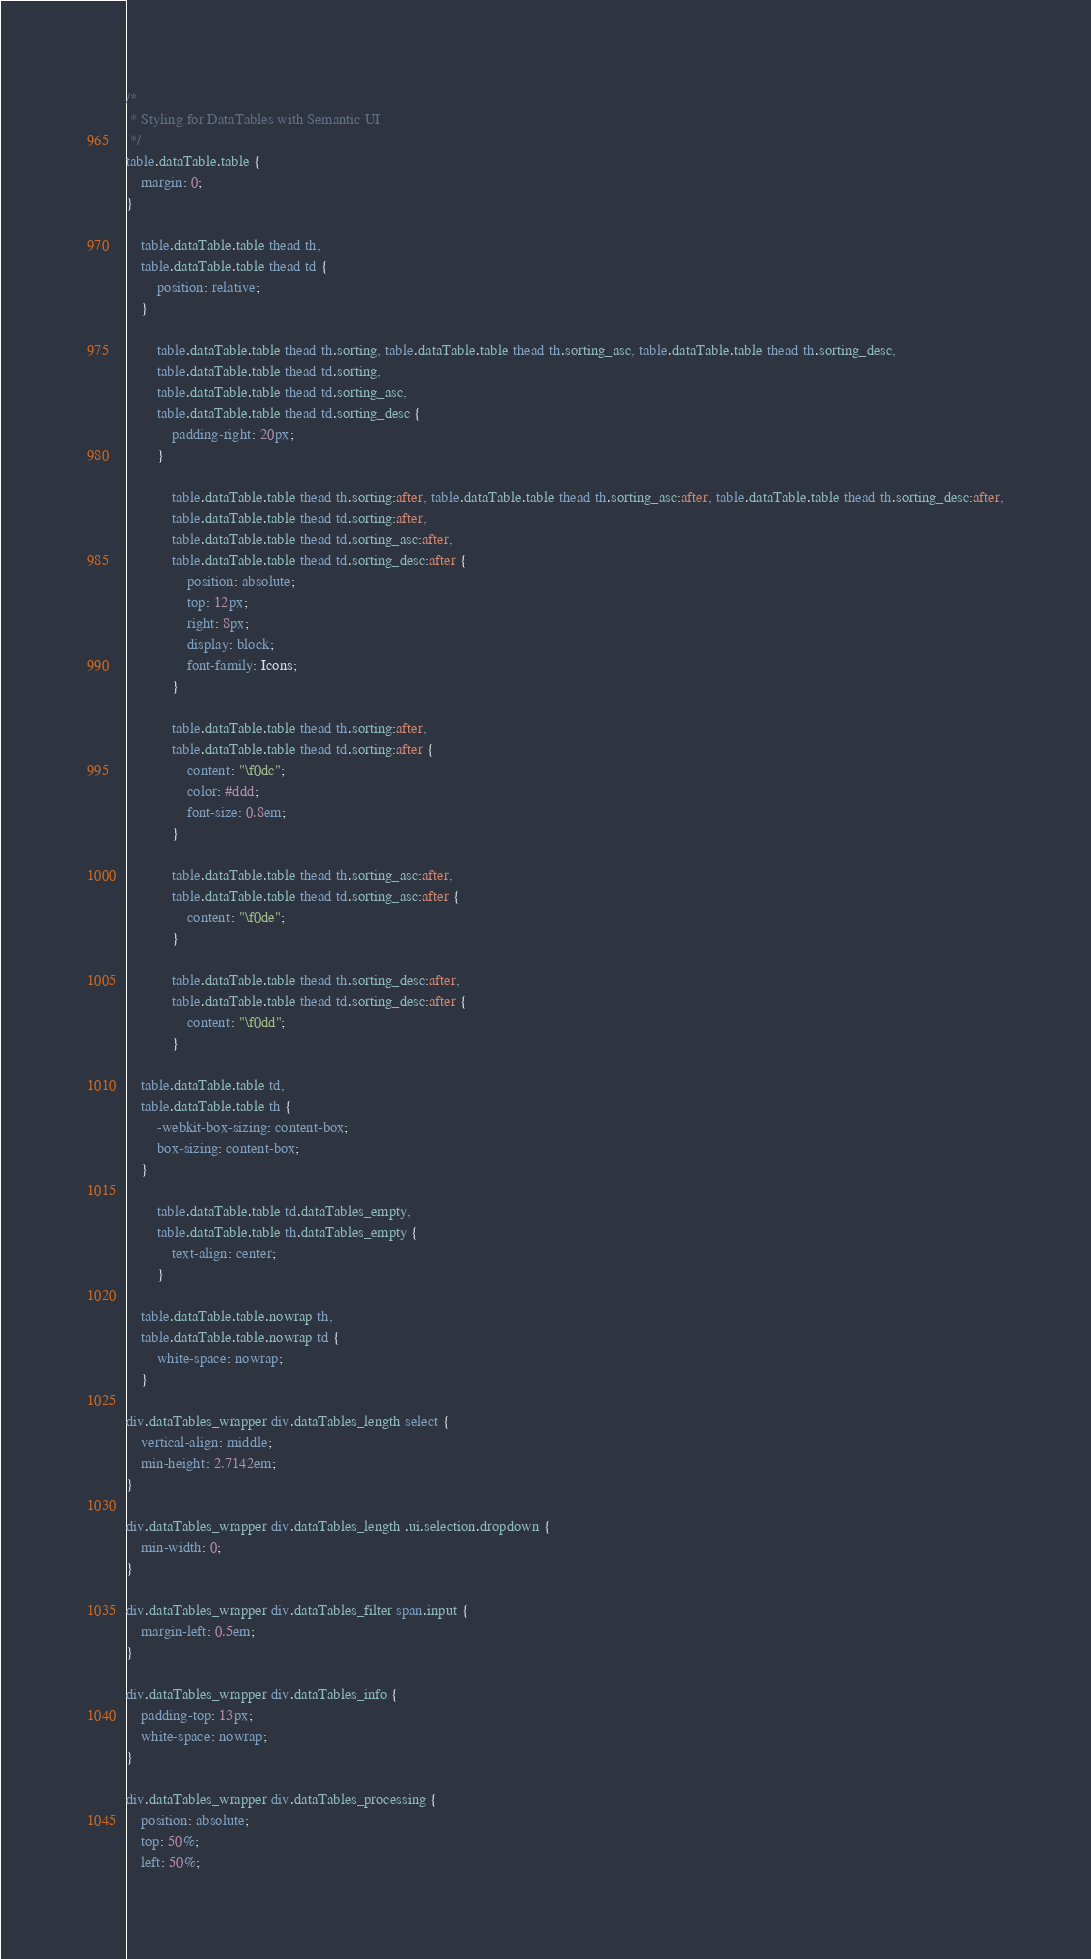<code> <loc_0><loc_0><loc_500><loc_500><_CSS_>/*
 * Styling for DataTables with Semantic UI
 */
table.dataTable.table {
    margin: 0;
}

    table.dataTable.table thead th,
    table.dataTable.table thead td {
        position: relative;
    }

        table.dataTable.table thead th.sorting, table.dataTable.table thead th.sorting_asc, table.dataTable.table thead th.sorting_desc,
        table.dataTable.table thead td.sorting,
        table.dataTable.table thead td.sorting_asc,
        table.dataTable.table thead td.sorting_desc {
            padding-right: 20px;
        }

            table.dataTable.table thead th.sorting:after, table.dataTable.table thead th.sorting_asc:after, table.dataTable.table thead th.sorting_desc:after,
            table.dataTable.table thead td.sorting:after,
            table.dataTable.table thead td.sorting_asc:after,
            table.dataTable.table thead td.sorting_desc:after {
                position: absolute;
                top: 12px;
                right: 8px;
                display: block;
                font-family: Icons;
            }

            table.dataTable.table thead th.sorting:after,
            table.dataTable.table thead td.sorting:after {
                content: "\f0dc";
                color: #ddd;
                font-size: 0.8em;
            }

            table.dataTable.table thead th.sorting_asc:after,
            table.dataTable.table thead td.sorting_asc:after {
                content: "\f0de";
            }

            table.dataTable.table thead th.sorting_desc:after,
            table.dataTable.table thead td.sorting_desc:after {
                content: "\f0dd";
            }

    table.dataTable.table td,
    table.dataTable.table th {
        -webkit-box-sizing: content-box;
        box-sizing: content-box;
    }

        table.dataTable.table td.dataTables_empty,
        table.dataTable.table th.dataTables_empty {
            text-align: center;
        }

    table.dataTable.table.nowrap th,
    table.dataTable.table.nowrap td {
        white-space: nowrap;
    }

div.dataTables_wrapper div.dataTables_length select {
    vertical-align: middle;
    min-height: 2.7142em;
}

div.dataTables_wrapper div.dataTables_length .ui.selection.dropdown {
    min-width: 0;
}

div.dataTables_wrapper div.dataTables_filter span.input {
    margin-left: 0.5em;
}

div.dataTables_wrapper div.dataTables_info {
    padding-top: 13px;
    white-space: nowrap;
}

div.dataTables_wrapper div.dataTables_processing {
    position: absolute;
    top: 50%;
    left: 50%;</code> 